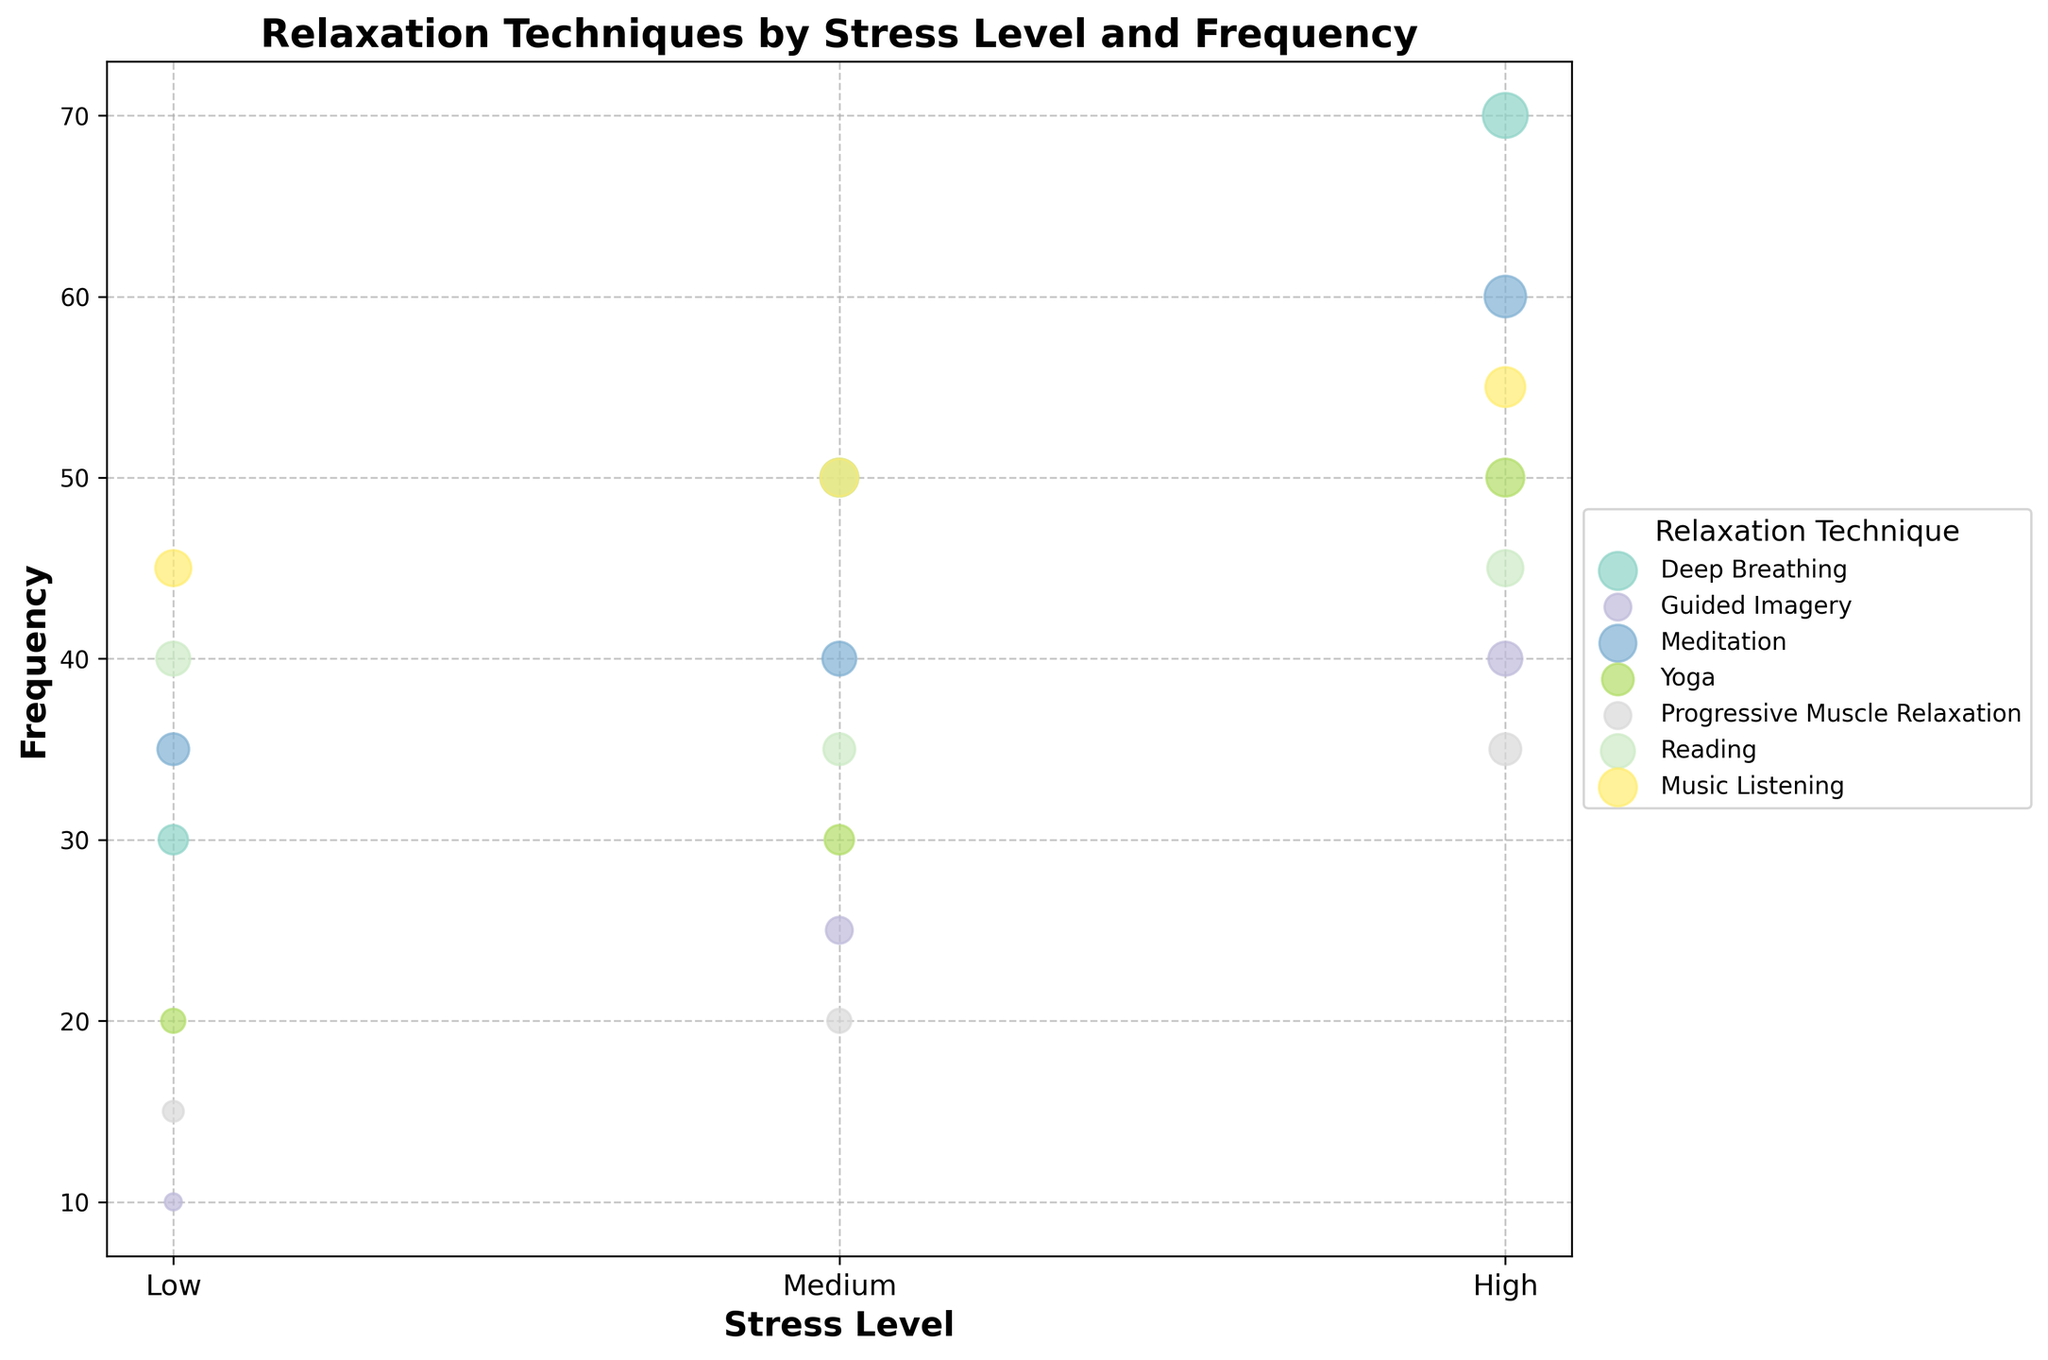What's the title of the figure? The title is usually displayed at the top of the chart. In our case, it reads "Relaxation Techniques by Stress Level and Frequency".
Answer: Relaxation Techniques by Stress Level and Frequency What are the labels on the x-axis? The x-axis shows three levels of stress: Low, Medium, and High. These are indicated by the ticks and their respective labels.
Answer: Low, Medium, High Which relaxation technique has the highest frequency for low stress levels? By examining the low stress level data points on the x-axis and the highest y-axis value, we find that "Music Listening" has a frequency of 45, making it the highest for low stress levels.
Answer: Music Listening How many relaxation techniques have a frequency greater than 50 for high stress levels? By inspecting the high stress level data points on the x-axis and checking their y-values, we find three techniques with frequencies greater than 50: Deep Breathing (70), Meditation (60), and Yoga (50). Thus, there are three techniques.
Answer: 3 Compare the frequency of Deep Breathing between low and high stress levels. Looking at both low and high stress level data points for Deep Breathing, the frequency is 30 for low stress and 70 for high stress. The difference between them is 70 - 30 = 40.
Answer: 40 Which relaxation technique shows the smallest increase in frequency from medium to high stress levels? By comparing the frequency differences from medium to high stress for each technique, we see:
- Deep Breathing: 70 - 50 = 20
- Guided Imagery: 40 - 25 = 15
- Meditation: 60 - 40 = 20
- Yoga: 50 - 30 = 20
- Progressive Muscle Relaxation: 35 - 20 = 15
- Reading: 45 - 35 = 10
- Music Listening: 55 - 50 = 5
Thus, the smallest increase is for Music Listening, which is 55 - 50 = 5.
Answer: Music Listening Which technique has the most consistent frequency across different stress levels? Consistency can be assessed by the variance of frequencies across stress levels. Upon examining:
- Deep Breathing: 30, 50, 70
- Guided Imagery: 10, 25, 40
- Meditation: 35, 40, 60
- Yoga: 20, 30, 50
- Progressive Muscle Relaxation: 15, 20, 35
- Reading: 40, 35, 45
- Music Listening: 45, 50, 55
Music Listening has the smallest range of variability (variance), with values of 45, 50, 55.
Answer: Music Listening What is the combined frequency of all relaxation techniques for medium stress levels? By adding frequencies for medium stress levels:
- Deep Breathing: 50
- Guided Imagery: 25
- Meditation: 40
- Yoga: 30
- Progressive Muscle Relaxation: 20
- Reading: 35
- Music Listening: 50
Hence, total frequency is 50 + 25 + 40 + 30 + 20 + 35 + 50 = 250.
Answer: 250 